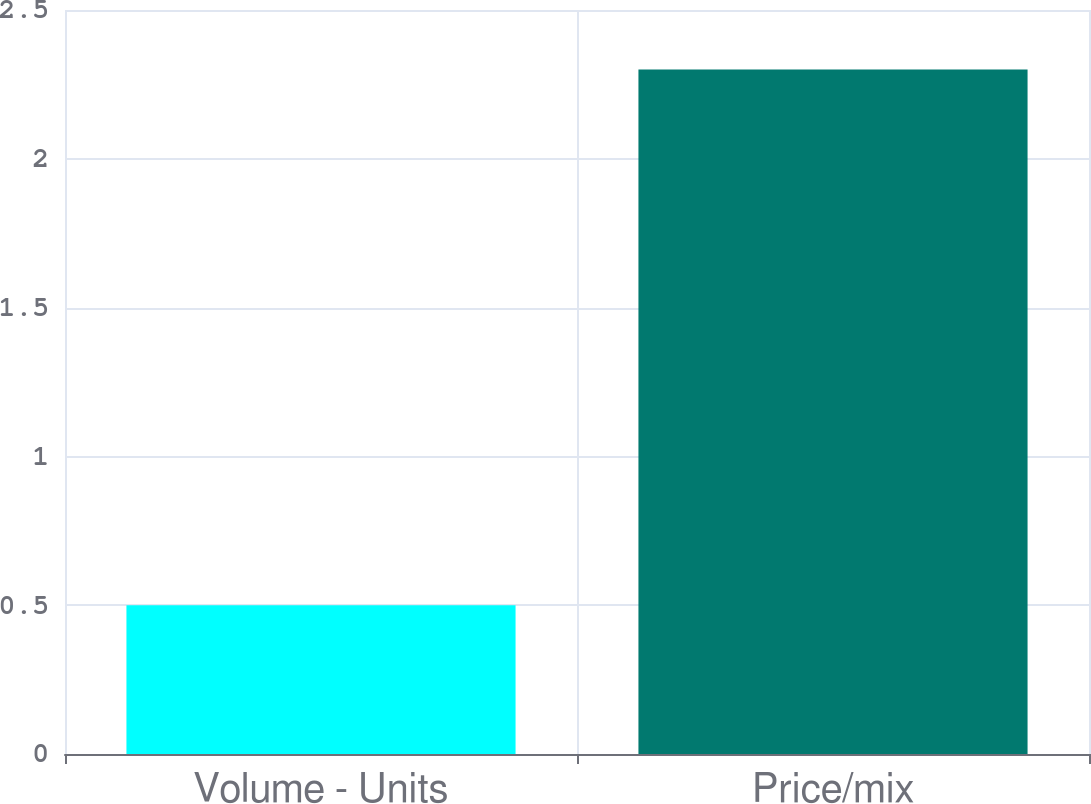<chart> <loc_0><loc_0><loc_500><loc_500><bar_chart><fcel>Volume - Units<fcel>Price/mix<nl><fcel>0.5<fcel>2.3<nl></chart> 